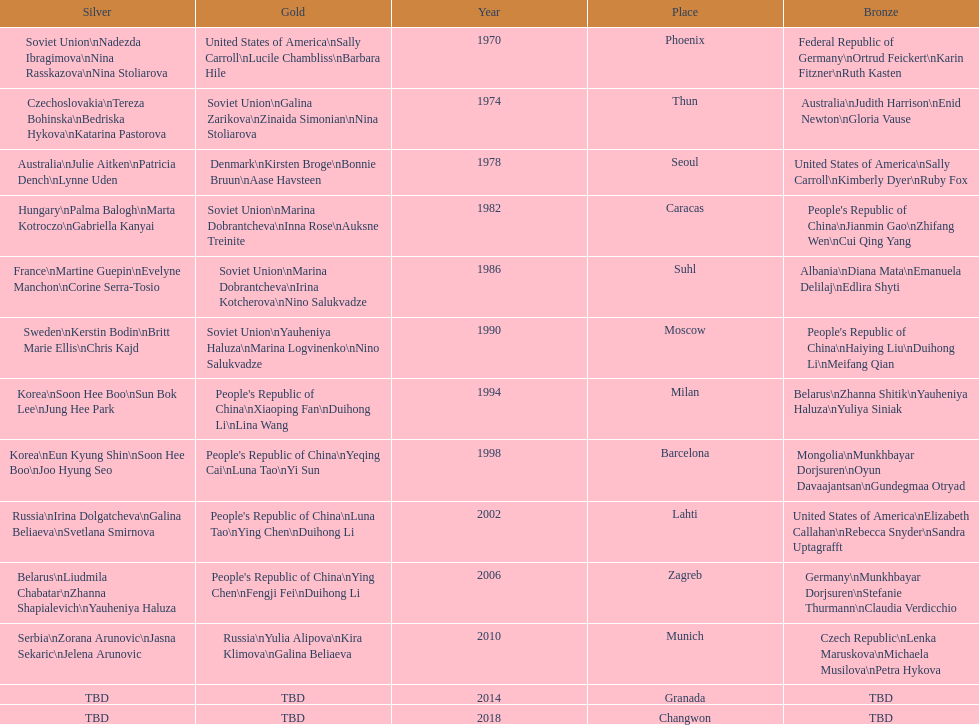What is the overall sum of bronze medals germany has achieved? 1. 